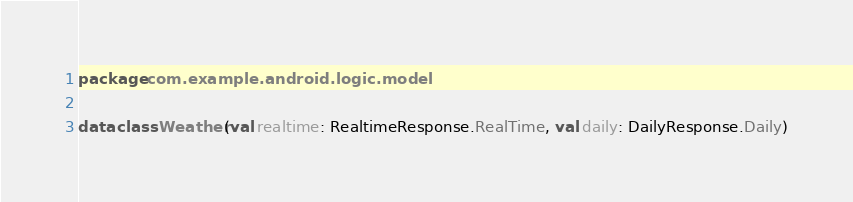<code> <loc_0><loc_0><loc_500><loc_500><_Kotlin_>package com.example.android.logic.model

data class Weather(val realtime: RealtimeResponse.RealTime, val daily: DailyResponse.Daily)
</code> 